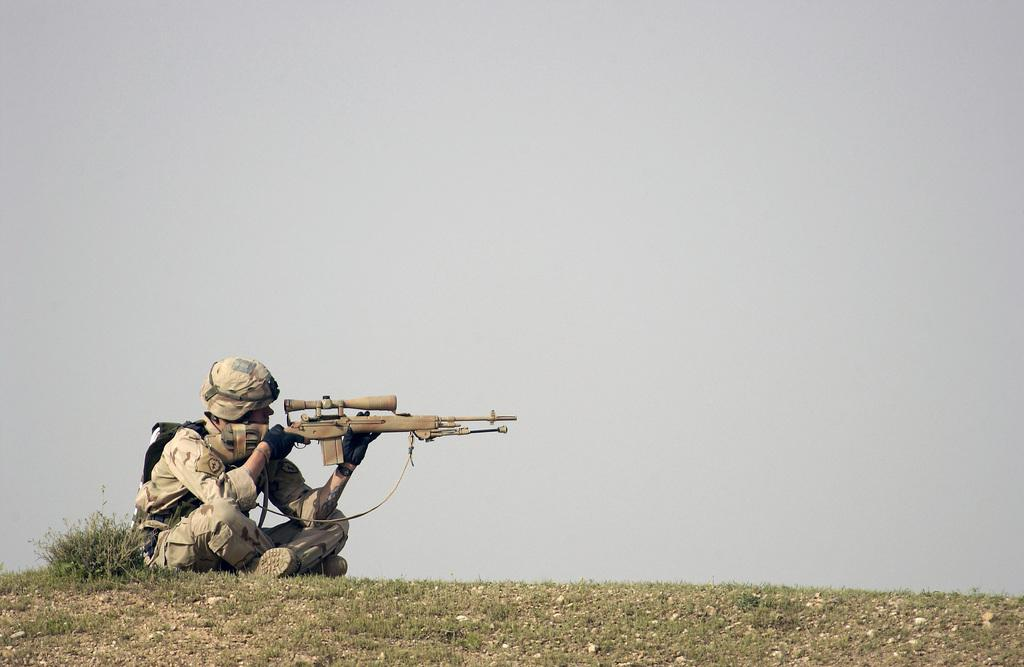What is the person in the image doing? The person is sitting on the ground. What accessories is the person wearing? The person is wearing gloves and a cap. What items is the person holding? The person is holding a bag and a gun. What type of surface is the person sitting on? There is grass on the ground, which the person is sitting on. What can be seen in the background of the image? The sky is visible in the background. What type of cough medicine is the person taking in the image? There is no cough medicine present in the image, and the person is not taking any medication. 